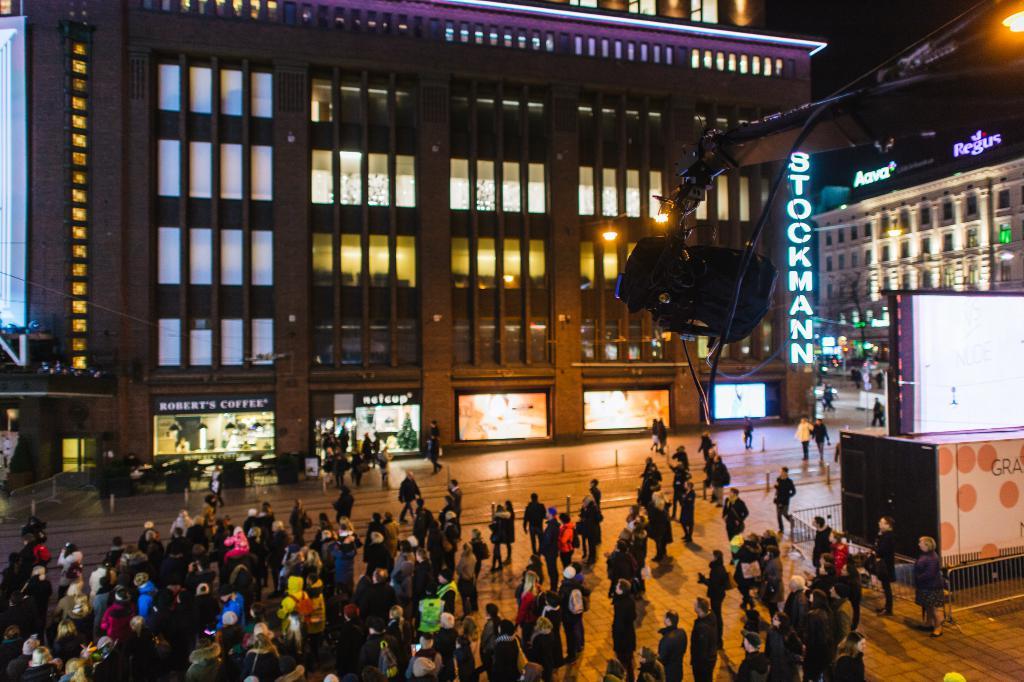Is there a regus building?
Ensure brevity in your answer.  Yes. What is the first letter on the vertical sign?
Ensure brevity in your answer.  S. 